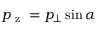Convert formula to latex. <formula><loc_0><loc_0><loc_500><loc_500>p _ { z } = p _ { \bot } \sin { \alpha }</formula> 